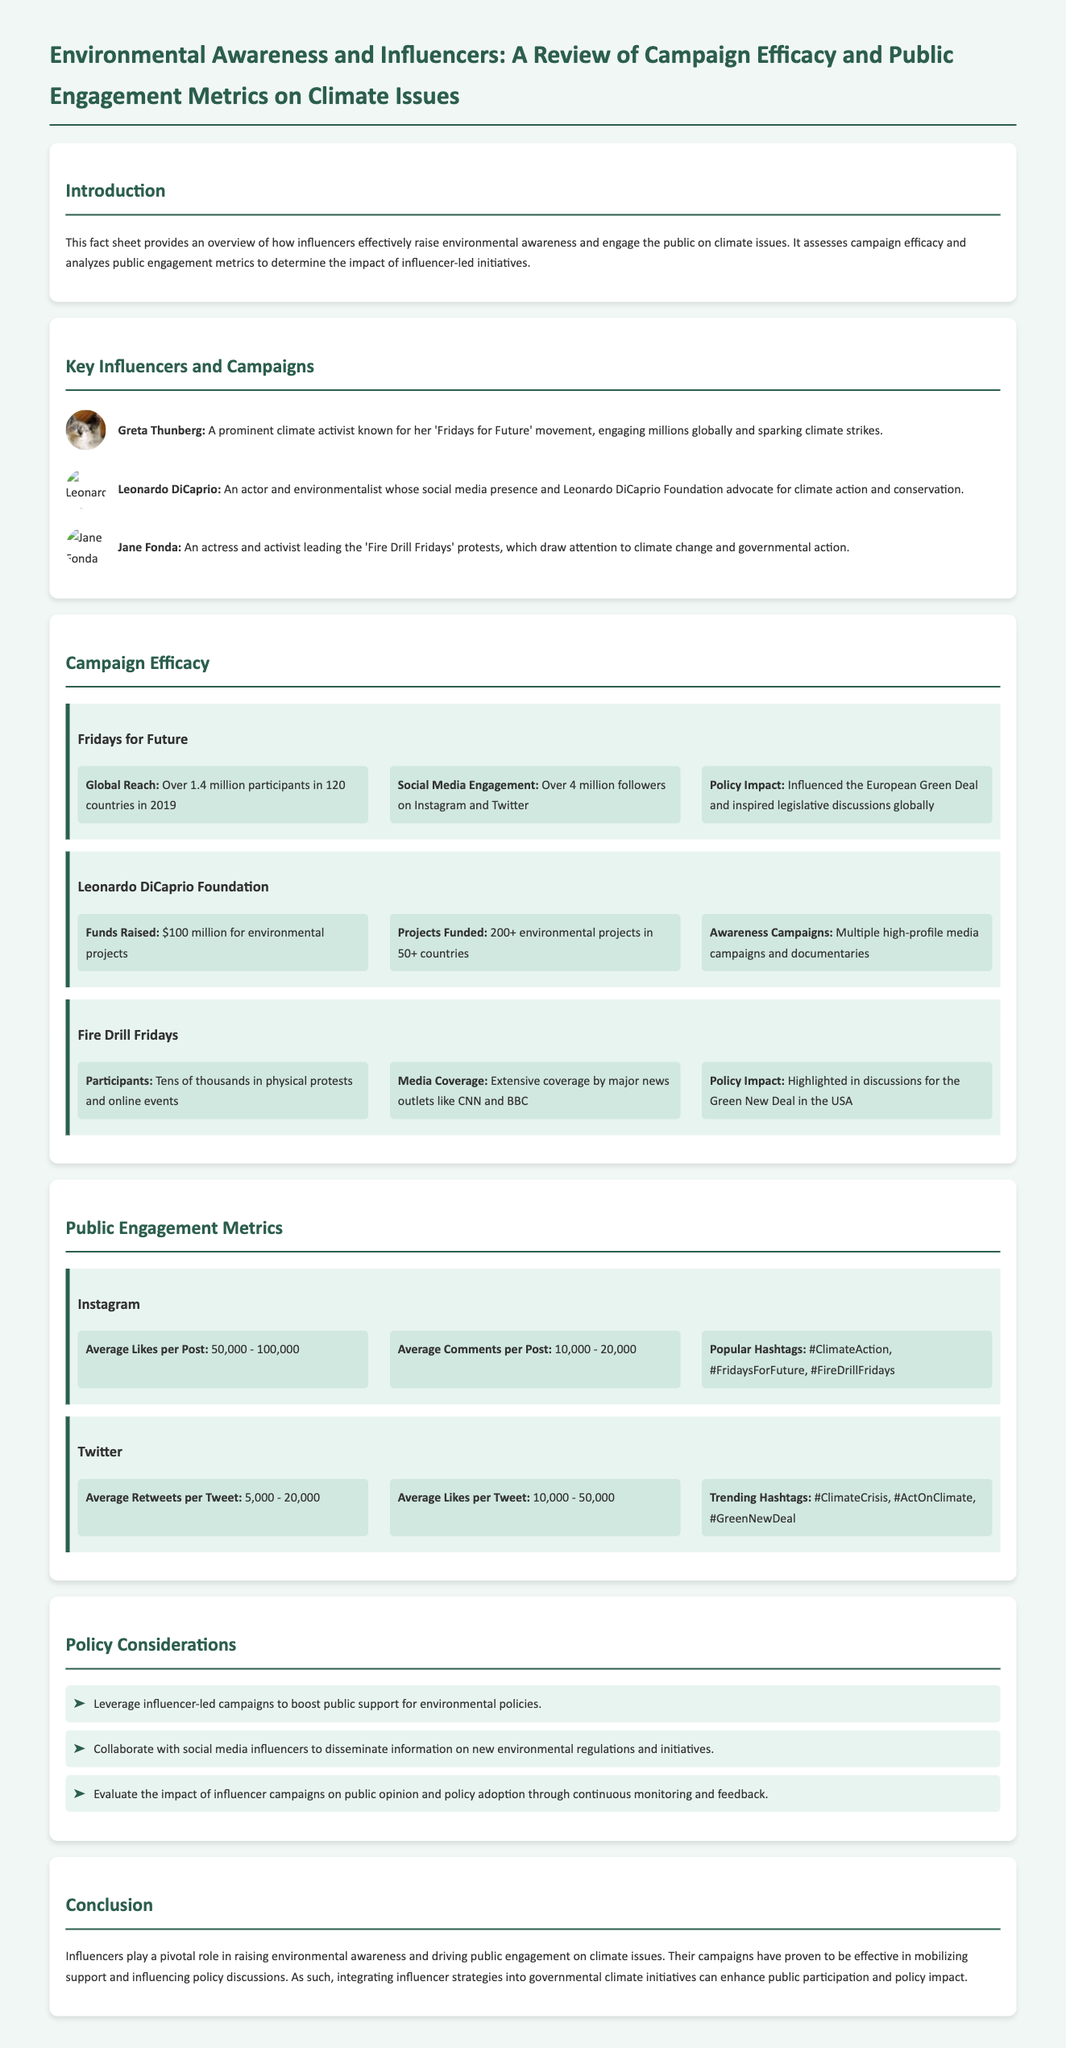what is the title of the document? The title of the document is provided in the header section.
Answer: Environmental Awareness and Influencers: A Review of Campaign Efficacy and Public Engagement Metrics on Climate Issues who is the primary influencer associated with 'Fridays for Future'? The section on key influencers lists Greta Thunberg as a primary influencer associated with this campaign.
Answer: Greta Thunberg what was the global reach of the 'Fridays for Future' campaign in 2019? The document states that the campaign had over 1.4 million participants in 120 countries.
Answer: Over 1.4 million participants how much money did the Leonardo DiCaprio Foundation raise for environmental projects? The document specifies that the foundation raised $100 million for environmental projects.
Answer: $100 million what is the average number of likes per tweet according to the Twitter metrics? The document indicates that the average likes per tweet range from 10,000 to 50,000.
Answer: 10,000 - 50,000 which policy is highlighted in relation to the impact of the 'Fire Drill Fridays'? The document mentions that the 'Fire Drill Fridays' campaign was highlighted in discussions for the Green New Deal in the USA.
Answer: Green New Deal what are popular hashtags mentioned for Instagram? The document lists #ClimateAction, #FridaysForFuture, and #FireDrillFridays as popular hashtags on Instagram.
Answer: #ClimateAction, #FridaysForFuture, #FireDrillFridays how many environmental projects has the Leonardo DiCaprio Foundation funded? According to the document, the foundation has funded over 200 environmental projects.
Answer: 200+ what recommendations are provided for policy considerations? The document lists three specific recommendations for government policy considerations related to influencers.
Answer: Leverage influencer-led campaigns, Collaborate with influencers, Evaluate impact what is the main conclusion regarding influencers in the document? The conclusion summarizes the role of influencers in raising awareness and engaging the public in climate issues.
Answer: Influencers play a pivotal role 